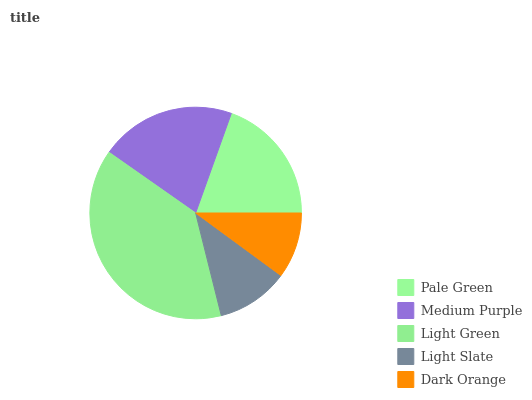Is Dark Orange the minimum?
Answer yes or no. Yes. Is Light Green the maximum?
Answer yes or no. Yes. Is Medium Purple the minimum?
Answer yes or no. No. Is Medium Purple the maximum?
Answer yes or no. No. Is Medium Purple greater than Pale Green?
Answer yes or no. Yes. Is Pale Green less than Medium Purple?
Answer yes or no. Yes. Is Pale Green greater than Medium Purple?
Answer yes or no. No. Is Medium Purple less than Pale Green?
Answer yes or no. No. Is Pale Green the high median?
Answer yes or no. Yes. Is Pale Green the low median?
Answer yes or no. Yes. Is Medium Purple the high median?
Answer yes or no. No. Is Medium Purple the low median?
Answer yes or no. No. 